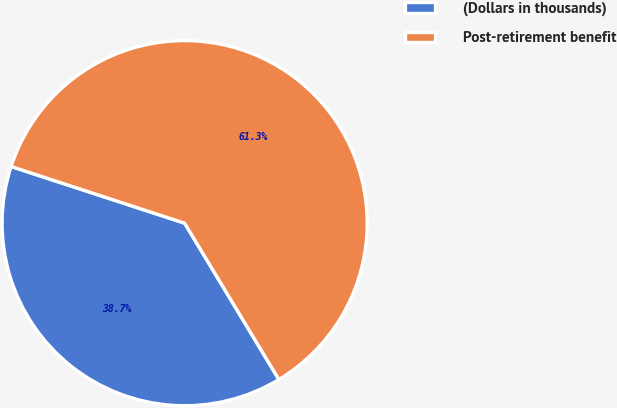<chart> <loc_0><loc_0><loc_500><loc_500><pie_chart><fcel>(Dollars in thousands)<fcel>Post-retirement benefit<nl><fcel>38.66%<fcel>61.34%<nl></chart> 